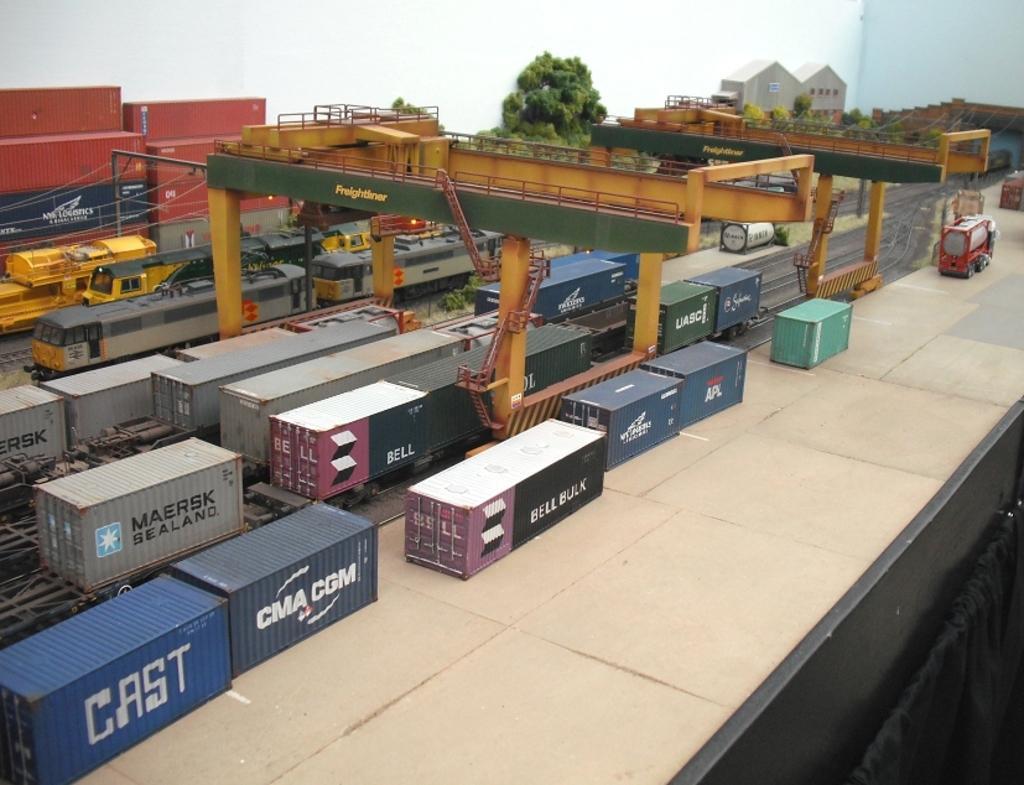How would you summarize this image in a sentence or two? In this image I can see a few trains and few containers on the railway track. They are in different color. I can see containers on the floor. I can see trees,houses and containers cranes 